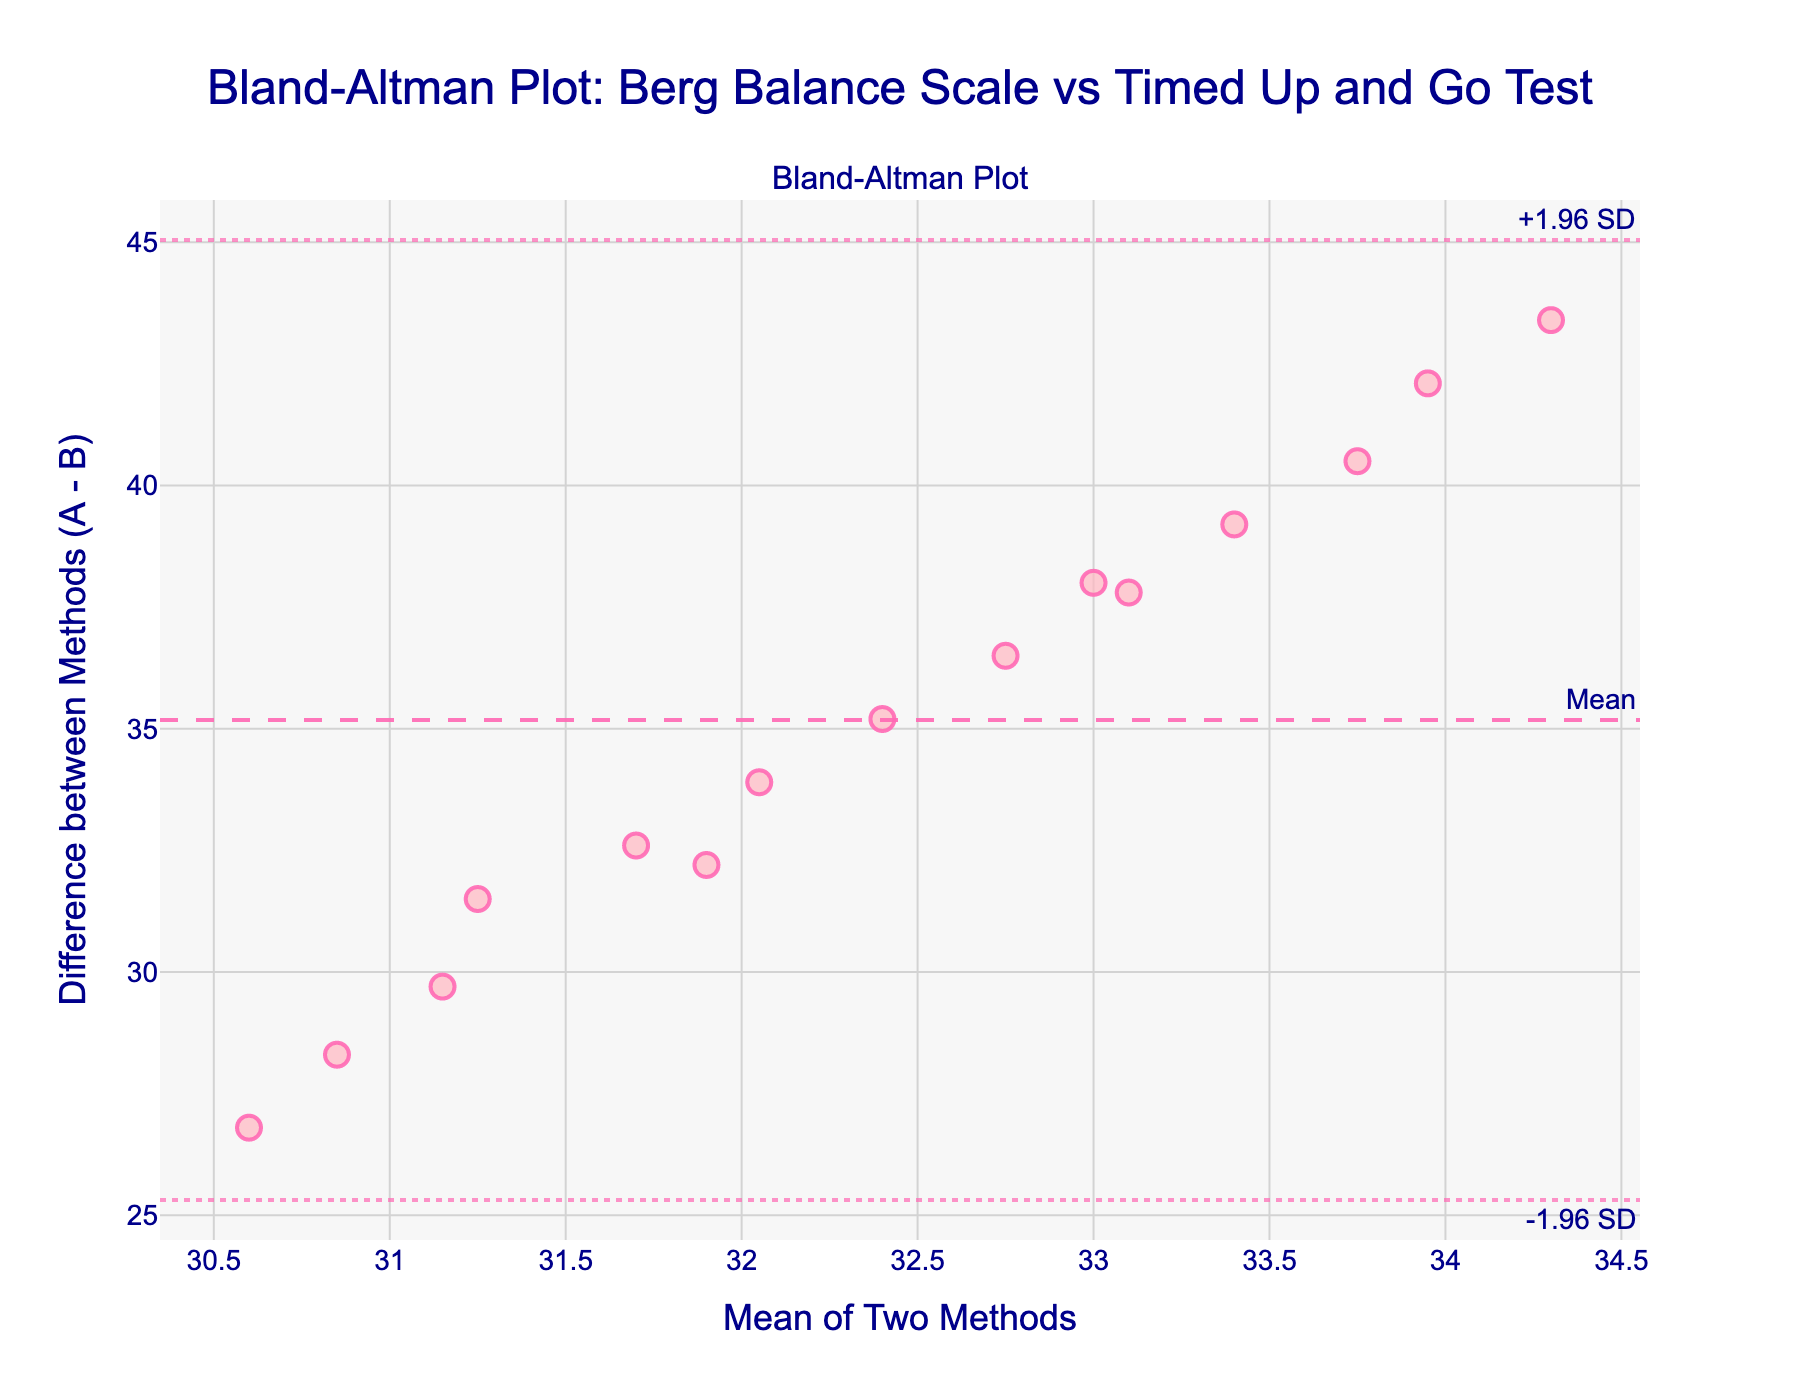What is the title of the figure? The title is given at the top of the figure in a large font size. It reads "Bland-Altman Plot: Berg Balance Scale vs Timed Up and Go Test".
Answer: Bland-Altman Plot: Berg Balance Scale vs Timed Up and Go Test How many data points are plotted on the graph? Each marker on the plot represents a data point. By counting all the markers, we can determine the number of data points.
Answer: 15 What is represented on the x-axis? The label on the x-axis provides this information. It reads "Mean of Two Methods", which indicates that the x-axis represents the average score of the two methods for each individual data point.
Answer: Mean of Two Methods What is represented on the y-axis? The label on the y-axis provides this information. It reads "Difference between Methods (A - B)", which indicates that the y-axis represents the difference between Method A and Method B for each individual data point.
Answer: Difference between Methods (A - B) What is the mean difference between the two methods? The mean difference is indicated by the dashed horizontal line annotated with "Mean". The y-value of this line represents the mean difference.
Answer: 37.02 How far apart are the limits of agreement on the plot? Calculate the distance between the +1.96 SD and -1.96 SD lines. These lines are represented by the dotted horizontal lines annotated with "+1.96 SD" and "-1.96 SD". Find the difference between their y-values. If +1.96 SD is 41.03 and -1.96 SD is 30.97, the range is 41.03 - 30.97.
Answer: 10.06 What does the mean line tell us? The mean line shows the average difference between Method A and Method B. This helps assess if there is a systematic bias between the methods. If the line is at y=0, there is no bias. Otherwise, the mean difference indicates the extent of the bias.
Answer: Systematic bias Is there any data point lying outside the limits of agreement? Examine whether any data points fall beyond the horizontal lines marked "+1.96 SD" and "-1.96 SD". Since all points are inside these lines, no data points lie outside the limits of agreement.
Answer: No Which limit of agreement has a higher value, +1.96 SD or -1.96 SD? Compare the y-values of the two lines. The "+1.96 SD" line is always higher than the "-1.96 SD" line, given their interpretations.
Answer: +1.96 SD 